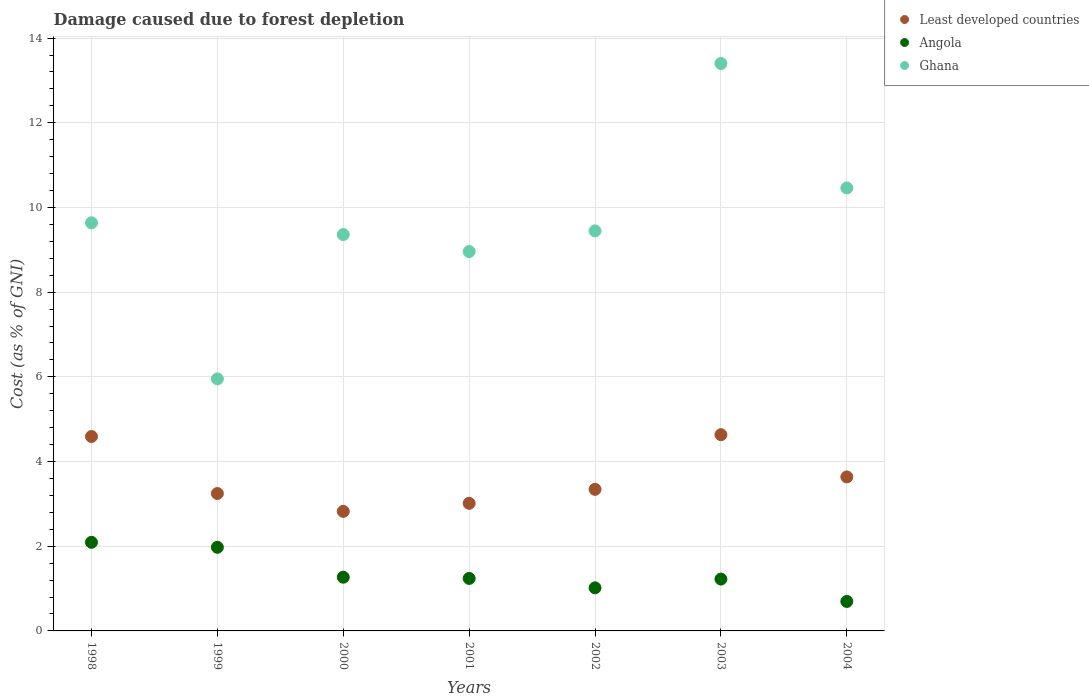Is the number of dotlines equal to the number of legend labels?
Provide a succinct answer. Yes. What is the cost of damage caused due to forest depletion in Least developed countries in 2002?
Make the answer very short. 3.34. Across all years, what is the maximum cost of damage caused due to forest depletion in Ghana?
Offer a very short reply. 13.4. Across all years, what is the minimum cost of damage caused due to forest depletion in Ghana?
Your response must be concise. 5.95. In which year was the cost of damage caused due to forest depletion in Ghana maximum?
Give a very brief answer. 2003. In which year was the cost of damage caused due to forest depletion in Angola minimum?
Your answer should be very brief. 2004. What is the total cost of damage caused due to forest depletion in Angola in the graph?
Your answer should be very brief. 9.51. What is the difference between the cost of damage caused due to forest depletion in Least developed countries in 1998 and that in 2000?
Offer a terse response. 1.77. What is the difference between the cost of damage caused due to forest depletion in Least developed countries in 1999 and the cost of damage caused due to forest depletion in Angola in 2000?
Offer a terse response. 1.98. What is the average cost of damage caused due to forest depletion in Ghana per year?
Make the answer very short. 9.6. In the year 2004, what is the difference between the cost of damage caused due to forest depletion in Angola and cost of damage caused due to forest depletion in Ghana?
Your answer should be very brief. -9.76. In how many years, is the cost of damage caused due to forest depletion in Least developed countries greater than 8 %?
Provide a short and direct response. 0. What is the ratio of the cost of damage caused due to forest depletion in Ghana in 1999 to that in 2001?
Ensure brevity in your answer.  0.66. Is the cost of damage caused due to forest depletion in Angola in 2000 less than that in 2004?
Your response must be concise. No. What is the difference between the highest and the second highest cost of damage caused due to forest depletion in Least developed countries?
Your answer should be very brief. 0.04. What is the difference between the highest and the lowest cost of damage caused due to forest depletion in Ghana?
Your answer should be compact. 7.45. Is the sum of the cost of damage caused due to forest depletion in Angola in 2002 and 2004 greater than the maximum cost of damage caused due to forest depletion in Ghana across all years?
Offer a very short reply. No. Is it the case that in every year, the sum of the cost of damage caused due to forest depletion in Angola and cost of damage caused due to forest depletion in Least developed countries  is greater than the cost of damage caused due to forest depletion in Ghana?
Give a very brief answer. No. Does the cost of damage caused due to forest depletion in Least developed countries monotonically increase over the years?
Ensure brevity in your answer.  No. Is the cost of damage caused due to forest depletion in Least developed countries strictly greater than the cost of damage caused due to forest depletion in Angola over the years?
Offer a very short reply. Yes. How many dotlines are there?
Ensure brevity in your answer.  3. What is the difference between two consecutive major ticks on the Y-axis?
Your answer should be compact. 2. Are the values on the major ticks of Y-axis written in scientific E-notation?
Give a very brief answer. No. Does the graph contain grids?
Provide a succinct answer. Yes. How many legend labels are there?
Your response must be concise. 3. What is the title of the graph?
Make the answer very short. Damage caused due to forest depletion. What is the label or title of the X-axis?
Keep it short and to the point. Years. What is the label or title of the Y-axis?
Provide a succinct answer. Cost (as % of GNI). What is the Cost (as % of GNI) in Least developed countries in 1998?
Give a very brief answer. 4.59. What is the Cost (as % of GNI) in Angola in 1998?
Your response must be concise. 2.09. What is the Cost (as % of GNI) in Ghana in 1998?
Give a very brief answer. 9.64. What is the Cost (as % of GNI) of Least developed countries in 1999?
Provide a succinct answer. 3.25. What is the Cost (as % of GNI) in Angola in 1999?
Offer a very short reply. 1.97. What is the Cost (as % of GNI) of Ghana in 1999?
Your answer should be compact. 5.95. What is the Cost (as % of GNI) of Least developed countries in 2000?
Keep it short and to the point. 2.82. What is the Cost (as % of GNI) in Angola in 2000?
Offer a terse response. 1.27. What is the Cost (as % of GNI) of Ghana in 2000?
Give a very brief answer. 9.36. What is the Cost (as % of GNI) in Least developed countries in 2001?
Provide a succinct answer. 3.01. What is the Cost (as % of GNI) of Angola in 2001?
Ensure brevity in your answer.  1.24. What is the Cost (as % of GNI) in Ghana in 2001?
Provide a succinct answer. 8.96. What is the Cost (as % of GNI) in Least developed countries in 2002?
Provide a short and direct response. 3.34. What is the Cost (as % of GNI) of Angola in 2002?
Make the answer very short. 1.02. What is the Cost (as % of GNI) in Ghana in 2002?
Ensure brevity in your answer.  9.45. What is the Cost (as % of GNI) in Least developed countries in 2003?
Your response must be concise. 4.63. What is the Cost (as % of GNI) of Angola in 2003?
Your answer should be very brief. 1.22. What is the Cost (as % of GNI) of Ghana in 2003?
Keep it short and to the point. 13.4. What is the Cost (as % of GNI) in Least developed countries in 2004?
Your answer should be very brief. 3.64. What is the Cost (as % of GNI) of Angola in 2004?
Make the answer very short. 0.7. What is the Cost (as % of GNI) of Ghana in 2004?
Give a very brief answer. 10.46. Across all years, what is the maximum Cost (as % of GNI) of Least developed countries?
Offer a terse response. 4.63. Across all years, what is the maximum Cost (as % of GNI) in Angola?
Provide a succinct answer. 2.09. Across all years, what is the maximum Cost (as % of GNI) of Ghana?
Make the answer very short. 13.4. Across all years, what is the minimum Cost (as % of GNI) of Least developed countries?
Provide a succinct answer. 2.82. Across all years, what is the minimum Cost (as % of GNI) of Angola?
Keep it short and to the point. 0.7. Across all years, what is the minimum Cost (as % of GNI) in Ghana?
Provide a succinct answer. 5.95. What is the total Cost (as % of GNI) in Least developed countries in the graph?
Make the answer very short. 25.29. What is the total Cost (as % of GNI) of Angola in the graph?
Provide a short and direct response. 9.51. What is the total Cost (as % of GNI) in Ghana in the graph?
Provide a short and direct response. 67.21. What is the difference between the Cost (as % of GNI) in Least developed countries in 1998 and that in 1999?
Offer a terse response. 1.35. What is the difference between the Cost (as % of GNI) of Angola in 1998 and that in 1999?
Make the answer very short. 0.12. What is the difference between the Cost (as % of GNI) in Ghana in 1998 and that in 1999?
Your response must be concise. 3.69. What is the difference between the Cost (as % of GNI) in Least developed countries in 1998 and that in 2000?
Keep it short and to the point. 1.77. What is the difference between the Cost (as % of GNI) of Angola in 1998 and that in 2000?
Make the answer very short. 0.82. What is the difference between the Cost (as % of GNI) of Ghana in 1998 and that in 2000?
Make the answer very short. 0.28. What is the difference between the Cost (as % of GNI) of Least developed countries in 1998 and that in 2001?
Keep it short and to the point. 1.58. What is the difference between the Cost (as % of GNI) in Angola in 1998 and that in 2001?
Your response must be concise. 0.85. What is the difference between the Cost (as % of GNI) of Ghana in 1998 and that in 2001?
Your answer should be compact. 0.68. What is the difference between the Cost (as % of GNI) in Least developed countries in 1998 and that in 2002?
Offer a very short reply. 1.25. What is the difference between the Cost (as % of GNI) in Angola in 1998 and that in 2002?
Your answer should be very brief. 1.07. What is the difference between the Cost (as % of GNI) in Ghana in 1998 and that in 2002?
Make the answer very short. 0.19. What is the difference between the Cost (as % of GNI) of Least developed countries in 1998 and that in 2003?
Your response must be concise. -0.04. What is the difference between the Cost (as % of GNI) in Angola in 1998 and that in 2003?
Your answer should be compact. 0.87. What is the difference between the Cost (as % of GNI) in Ghana in 1998 and that in 2003?
Provide a succinct answer. -3.76. What is the difference between the Cost (as % of GNI) in Least developed countries in 1998 and that in 2004?
Your answer should be very brief. 0.95. What is the difference between the Cost (as % of GNI) in Angola in 1998 and that in 2004?
Provide a succinct answer. 1.4. What is the difference between the Cost (as % of GNI) of Ghana in 1998 and that in 2004?
Keep it short and to the point. -0.82. What is the difference between the Cost (as % of GNI) of Least developed countries in 1999 and that in 2000?
Your response must be concise. 0.42. What is the difference between the Cost (as % of GNI) of Angola in 1999 and that in 2000?
Provide a short and direct response. 0.71. What is the difference between the Cost (as % of GNI) of Ghana in 1999 and that in 2000?
Ensure brevity in your answer.  -3.41. What is the difference between the Cost (as % of GNI) in Least developed countries in 1999 and that in 2001?
Provide a succinct answer. 0.23. What is the difference between the Cost (as % of GNI) in Angola in 1999 and that in 2001?
Your answer should be very brief. 0.74. What is the difference between the Cost (as % of GNI) of Ghana in 1999 and that in 2001?
Offer a terse response. -3.01. What is the difference between the Cost (as % of GNI) in Least developed countries in 1999 and that in 2002?
Keep it short and to the point. -0.1. What is the difference between the Cost (as % of GNI) of Angola in 1999 and that in 2002?
Give a very brief answer. 0.96. What is the difference between the Cost (as % of GNI) in Ghana in 1999 and that in 2002?
Offer a very short reply. -3.49. What is the difference between the Cost (as % of GNI) in Least developed countries in 1999 and that in 2003?
Your response must be concise. -1.39. What is the difference between the Cost (as % of GNI) in Angola in 1999 and that in 2003?
Your response must be concise. 0.75. What is the difference between the Cost (as % of GNI) in Ghana in 1999 and that in 2003?
Provide a succinct answer. -7.45. What is the difference between the Cost (as % of GNI) of Least developed countries in 1999 and that in 2004?
Give a very brief answer. -0.39. What is the difference between the Cost (as % of GNI) of Angola in 1999 and that in 2004?
Your answer should be compact. 1.28. What is the difference between the Cost (as % of GNI) in Ghana in 1999 and that in 2004?
Provide a short and direct response. -4.51. What is the difference between the Cost (as % of GNI) in Least developed countries in 2000 and that in 2001?
Make the answer very short. -0.19. What is the difference between the Cost (as % of GNI) of Angola in 2000 and that in 2001?
Give a very brief answer. 0.03. What is the difference between the Cost (as % of GNI) in Ghana in 2000 and that in 2001?
Your response must be concise. 0.4. What is the difference between the Cost (as % of GNI) in Least developed countries in 2000 and that in 2002?
Offer a very short reply. -0.52. What is the difference between the Cost (as % of GNI) in Angola in 2000 and that in 2002?
Give a very brief answer. 0.25. What is the difference between the Cost (as % of GNI) of Ghana in 2000 and that in 2002?
Ensure brevity in your answer.  -0.09. What is the difference between the Cost (as % of GNI) in Least developed countries in 2000 and that in 2003?
Give a very brief answer. -1.81. What is the difference between the Cost (as % of GNI) in Angola in 2000 and that in 2003?
Provide a short and direct response. 0.04. What is the difference between the Cost (as % of GNI) of Ghana in 2000 and that in 2003?
Provide a succinct answer. -4.04. What is the difference between the Cost (as % of GNI) in Least developed countries in 2000 and that in 2004?
Offer a terse response. -0.81. What is the difference between the Cost (as % of GNI) in Angola in 2000 and that in 2004?
Give a very brief answer. 0.57. What is the difference between the Cost (as % of GNI) in Ghana in 2000 and that in 2004?
Your response must be concise. -1.1. What is the difference between the Cost (as % of GNI) of Least developed countries in 2001 and that in 2002?
Ensure brevity in your answer.  -0.33. What is the difference between the Cost (as % of GNI) in Angola in 2001 and that in 2002?
Provide a succinct answer. 0.22. What is the difference between the Cost (as % of GNI) of Ghana in 2001 and that in 2002?
Offer a terse response. -0.49. What is the difference between the Cost (as % of GNI) in Least developed countries in 2001 and that in 2003?
Ensure brevity in your answer.  -1.62. What is the difference between the Cost (as % of GNI) in Angola in 2001 and that in 2003?
Keep it short and to the point. 0.01. What is the difference between the Cost (as % of GNI) in Ghana in 2001 and that in 2003?
Give a very brief answer. -4.44. What is the difference between the Cost (as % of GNI) in Least developed countries in 2001 and that in 2004?
Provide a succinct answer. -0.62. What is the difference between the Cost (as % of GNI) of Angola in 2001 and that in 2004?
Provide a succinct answer. 0.54. What is the difference between the Cost (as % of GNI) in Ghana in 2001 and that in 2004?
Your answer should be very brief. -1.5. What is the difference between the Cost (as % of GNI) of Least developed countries in 2002 and that in 2003?
Your answer should be very brief. -1.29. What is the difference between the Cost (as % of GNI) in Angola in 2002 and that in 2003?
Offer a terse response. -0.21. What is the difference between the Cost (as % of GNI) in Ghana in 2002 and that in 2003?
Your answer should be very brief. -3.95. What is the difference between the Cost (as % of GNI) of Least developed countries in 2002 and that in 2004?
Make the answer very short. -0.29. What is the difference between the Cost (as % of GNI) in Angola in 2002 and that in 2004?
Provide a succinct answer. 0.32. What is the difference between the Cost (as % of GNI) in Ghana in 2002 and that in 2004?
Keep it short and to the point. -1.01. What is the difference between the Cost (as % of GNI) of Least developed countries in 2003 and that in 2004?
Give a very brief answer. 1. What is the difference between the Cost (as % of GNI) of Angola in 2003 and that in 2004?
Offer a terse response. 0.53. What is the difference between the Cost (as % of GNI) of Ghana in 2003 and that in 2004?
Provide a succinct answer. 2.94. What is the difference between the Cost (as % of GNI) of Least developed countries in 1998 and the Cost (as % of GNI) of Angola in 1999?
Make the answer very short. 2.62. What is the difference between the Cost (as % of GNI) of Least developed countries in 1998 and the Cost (as % of GNI) of Ghana in 1999?
Your answer should be very brief. -1.36. What is the difference between the Cost (as % of GNI) of Angola in 1998 and the Cost (as % of GNI) of Ghana in 1999?
Offer a terse response. -3.86. What is the difference between the Cost (as % of GNI) in Least developed countries in 1998 and the Cost (as % of GNI) in Angola in 2000?
Offer a very short reply. 3.32. What is the difference between the Cost (as % of GNI) in Least developed countries in 1998 and the Cost (as % of GNI) in Ghana in 2000?
Your answer should be compact. -4.77. What is the difference between the Cost (as % of GNI) of Angola in 1998 and the Cost (as % of GNI) of Ghana in 2000?
Offer a terse response. -7.27. What is the difference between the Cost (as % of GNI) of Least developed countries in 1998 and the Cost (as % of GNI) of Angola in 2001?
Your response must be concise. 3.35. What is the difference between the Cost (as % of GNI) of Least developed countries in 1998 and the Cost (as % of GNI) of Ghana in 2001?
Make the answer very short. -4.37. What is the difference between the Cost (as % of GNI) in Angola in 1998 and the Cost (as % of GNI) in Ghana in 2001?
Keep it short and to the point. -6.87. What is the difference between the Cost (as % of GNI) of Least developed countries in 1998 and the Cost (as % of GNI) of Angola in 2002?
Provide a short and direct response. 3.57. What is the difference between the Cost (as % of GNI) in Least developed countries in 1998 and the Cost (as % of GNI) in Ghana in 2002?
Ensure brevity in your answer.  -4.86. What is the difference between the Cost (as % of GNI) in Angola in 1998 and the Cost (as % of GNI) in Ghana in 2002?
Offer a very short reply. -7.35. What is the difference between the Cost (as % of GNI) of Least developed countries in 1998 and the Cost (as % of GNI) of Angola in 2003?
Ensure brevity in your answer.  3.37. What is the difference between the Cost (as % of GNI) of Least developed countries in 1998 and the Cost (as % of GNI) of Ghana in 2003?
Provide a short and direct response. -8.81. What is the difference between the Cost (as % of GNI) in Angola in 1998 and the Cost (as % of GNI) in Ghana in 2003?
Provide a succinct answer. -11.31. What is the difference between the Cost (as % of GNI) in Least developed countries in 1998 and the Cost (as % of GNI) in Angola in 2004?
Give a very brief answer. 3.9. What is the difference between the Cost (as % of GNI) in Least developed countries in 1998 and the Cost (as % of GNI) in Ghana in 2004?
Keep it short and to the point. -5.87. What is the difference between the Cost (as % of GNI) in Angola in 1998 and the Cost (as % of GNI) in Ghana in 2004?
Provide a succinct answer. -8.37. What is the difference between the Cost (as % of GNI) of Least developed countries in 1999 and the Cost (as % of GNI) of Angola in 2000?
Offer a terse response. 1.98. What is the difference between the Cost (as % of GNI) of Least developed countries in 1999 and the Cost (as % of GNI) of Ghana in 2000?
Your answer should be very brief. -6.11. What is the difference between the Cost (as % of GNI) of Angola in 1999 and the Cost (as % of GNI) of Ghana in 2000?
Provide a short and direct response. -7.38. What is the difference between the Cost (as % of GNI) in Least developed countries in 1999 and the Cost (as % of GNI) in Angola in 2001?
Ensure brevity in your answer.  2.01. What is the difference between the Cost (as % of GNI) in Least developed countries in 1999 and the Cost (as % of GNI) in Ghana in 2001?
Your answer should be compact. -5.71. What is the difference between the Cost (as % of GNI) of Angola in 1999 and the Cost (as % of GNI) of Ghana in 2001?
Give a very brief answer. -6.98. What is the difference between the Cost (as % of GNI) in Least developed countries in 1999 and the Cost (as % of GNI) in Angola in 2002?
Your answer should be compact. 2.23. What is the difference between the Cost (as % of GNI) in Least developed countries in 1999 and the Cost (as % of GNI) in Ghana in 2002?
Provide a short and direct response. -6.2. What is the difference between the Cost (as % of GNI) in Angola in 1999 and the Cost (as % of GNI) in Ghana in 2002?
Give a very brief answer. -7.47. What is the difference between the Cost (as % of GNI) in Least developed countries in 1999 and the Cost (as % of GNI) in Angola in 2003?
Make the answer very short. 2.02. What is the difference between the Cost (as % of GNI) of Least developed countries in 1999 and the Cost (as % of GNI) of Ghana in 2003?
Your response must be concise. -10.16. What is the difference between the Cost (as % of GNI) in Angola in 1999 and the Cost (as % of GNI) in Ghana in 2003?
Provide a succinct answer. -11.43. What is the difference between the Cost (as % of GNI) of Least developed countries in 1999 and the Cost (as % of GNI) of Angola in 2004?
Offer a terse response. 2.55. What is the difference between the Cost (as % of GNI) in Least developed countries in 1999 and the Cost (as % of GNI) in Ghana in 2004?
Your answer should be very brief. -7.22. What is the difference between the Cost (as % of GNI) of Angola in 1999 and the Cost (as % of GNI) of Ghana in 2004?
Your answer should be compact. -8.49. What is the difference between the Cost (as % of GNI) in Least developed countries in 2000 and the Cost (as % of GNI) in Angola in 2001?
Give a very brief answer. 1.58. What is the difference between the Cost (as % of GNI) in Least developed countries in 2000 and the Cost (as % of GNI) in Ghana in 2001?
Make the answer very short. -6.14. What is the difference between the Cost (as % of GNI) in Angola in 2000 and the Cost (as % of GNI) in Ghana in 2001?
Provide a succinct answer. -7.69. What is the difference between the Cost (as % of GNI) in Least developed countries in 2000 and the Cost (as % of GNI) in Angola in 2002?
Keep it short and to the point. 1.81. What is the difference between the Cost (as % of GNI) in Least developed countries in 2000 and the Cost (as % of GNI) in Ghana in 2002?
Your response must be concise. -6.62. What is the difference between the Cost (as % of GNI) in Angola in 2000 and the Cost (as % of GNI) in Ghana in 2002?
Provide a succinct answer. -8.18. What is the difference between the Cost (as % of GNI) of Least developed countries in 2000 and the Cost (as % of GNI) of Angola in 2003?
Your response must be concise. 1.6. What is the difference between the Cost (as % of GNI) of Least developed countries in 2000 and the Cost (as % of GNI) of Ghana in 2003?
Provide a succinct answer. -10.58. What is the difference between the Cost (as % of GNI) in Angola in 2000 and the Cost (as % of GNI) in Ghana in 2003?
Give a very brief answer. -12.13. What is the difference between the Cost (as % of GNI) in Least developed countries in 2000 and the Cost (as % of GNI) in Angola in 2004?
Provide a short and direct response. 2.13. What is the difference between the Cost (as % of GNI) in Least developed countries in 2000 and the Cost (as % of GNI) in Ghana in 2004?
Your response must be concise. -7.64. What is the difference between the Cost (as % of GNI) in Angola in 2000 and the Cost (as % of GNI) in Ghana in 2004?
Give a very brief answer. -9.19. What is the difference between the Cost (as % of GNI) in Least developed countries in 2001 and the Cost (as % of GNI) in Angola in 2002?
Offer a terse response. 2. What is the difference between the Cost (as % of GNI) in Least developed countries in 2001 and the Cost (as % of GNI) in Ghana in 2002?
Your answer should be very brief. -6.43. What is the difference between the Cost (as % of GNI) in Angola in 2001 and the Cost (as % of GNI) in Ghana in 2002?
Keep it short and to the point. -8.21. What is the difference between the Cost (as % of GNI) in Least developed countries in 2001 and the Cost (as % of GNI) in Angola in 2003?
Offer a very short reply. 1.79. What is the difference between the Cost (as % of GNI) in Least developed countries in 2001 and the Cost (as % of GNI) in Ghana in 2003?
Offer a terse response. -10.39. What is the difference between the Cost (as % of GNI) of Angola in 2001 and the Cost (as % of GNI) of Ghana in 2003?
Ensure brevity in your answer.  -12.16. What is the difference between the Cost (as % of GNI) in Least developed countries in 2001 and the Cost (as % of GNI) in Angola in 2004?
Offer a terse response. 2.32. What is the difference between the Cost (as % of GNI) of Least developed countries in 2001 and the Cost (as % of GNI) of Ghana in 2004?
Give a very brief answer. -7.45. What is the difference between the Cost (as % of GNI) of Angola in 2001 and the Cost (as % of GNI) of Ghana in 2004?
Provide a succinct answer. -9.22. What is the difference between the Cost (as % of GNI) of Least developed countries in 2002 and the Cost (as % of GNI) of Angola in 2003?
Ensure brevity in your answer.  2.12. What is the difference between the Cost (as % of GNI) of Least developed countries in 2002 and the Cost (as % of GNI) of Ghana in 2003?
Your answer should be very brief. -10.06. What is the difference between the Cost (as % of GNI) of Angola in 2002 and the Cost (as % of GNI) of Ghana in 2003?
Provide a short and direct response. -12.38. What is the difference between the Cost (as % of GNI) in Least developed countries in 2002 and the Cost (as % of GNI) in Angola in 2004?
Your answer should be compact. 2.65. What is the difference between the Cost (as % of GNI) in Least developed countries in 2002 and the Cost (as % of GNI) in Ghana in 2004?
Your response must be concise. -7.12. What is the difference between the Cost (as % of GNI) of Angola in 2002 and the Cost (as % of GNI) of Ghana in 2004?
Your answer should be compact. -9.44. What is the difference between the Cost (as % of GNI) in Least developed countries in 2003 and the Cost (as % of GNI) in Angola in 2004?
Keep it short and to the point. 3.94. What is the difference between the Cost (as % of GNI) of Least developed countries in 2003 and the Cost (as % of GNI) of Ghana in 2004?
Your answer should be compact. -5.83. What is the difference between the Cost (as % of GNI) in Angola in 2003 and the Cost (as % of GNI) in Ghana in 2004?
Your response must be concise. -9.24. What is the average Cost (as % of GNI) in Least developed countries per year?
Provide a short and direct response. 3.61. What is the average Cost (as % of GNI) in Angola per year?
Your response must be concise. 1.36. What is the average Cost (as % of GNI) in Ghana per year?
Offer a terse response. 9.6. In the year 1998, what is the difference between the Cost (as % of GNI) of Least developed countries and Cost (as % of GNI) of Angola?
Ensure brevity in your answer.  2.5. In the year 1998, what is the difference between the Cost (as % of GNI) in Least developed countries and Cost (as % of GNI) in Ghana?
Keep it short and to the point. -5.05. In the year 1998, what is the difference between the Cost (as % of GNI) of Angola and Cost (as % of GNI) of Ghana?
Offer a terse response. -7.54. In the year 1999, what is the difference between the Cost (as % of GNI) in Least developed countries and Cost (as % of GNI) in Angola?
Make the answer very short. 1.27. In the year 1999, what is the difference between the Cost (as % of GNI) of Least developed countries and Cost (as % of GNI) of Ghana?
Keep it short and to the point. -2.71. In the year 1999, what is the difference between the Cost (as % of GNI) of Angola and Cost (as % of GNI) of Ghana?
Your response must be concise. -3.98. In the year 2000, what is the difference between the Cost (as % of GNI) in Least developed countries and Cost (as % of GNI) in Angola?
Provide a succinct answer. 1.55. In the year 2000, what is the difference between the Cost (as % of GNI) of Least developed countries and Cost (as % of GNI) of Ghana?
Your response must be concise. -6.54. In the year 2000, what is the difference between the Cost (as % of GNI) in Angola and Cost (as % of GNI) in Ghana?
Your answer should be very brief. -8.09. In the year 2001, what is the difference between the Cost (as % of GNI) of Least developed countries and Cost (as % of GNI) of Angola?
Your response must be concise. 1.77. In the year 2001, what is the difference between the Cost (as % of GNI) of Least developed countries and Cost (as % of GNI) of Ghana?
Ensure brevity in your answer.  -5.95. In the year 2001, what is the difference between the Cost (as % of GNI) in Angola and Cost (as % of GNI) in Ghana?
Offer a very short reply. -7.72. In the year 2002, what is the difference between the Cost (as % of GNI) of Least developed countries and Cost (as % of GNI) of Angola?
Give a very brief answer. 2.33. In the year 2002, what is the difference between the Cost (as % of GNI) in Least developed countries and Cost (as % of GNI) in Ghana?
Provide a short and direct response. -6.1. In the year 2002, what is the difference between the Cost (as % of GNI) in Angola and Cost (as % of GNI) in Ghana?
Keep it short and to the point. -8.43. In the year 2003, what is the difference between the Cost (as % of GNI) in Least developed countries and Cost (as % of GNI) in Angola?
Provide a short and direct response. 3.41. In the year 2003, what is the difference between the Cost (as % of GNI) in Least developed countries and Cost (as % of GNI) in Ghana?
Offer a very short reply. -8.77. In the year 2003, what is the difference between the Cost (as % of GNI) of Angola and Cost (as % of GNI) of Ghana?
Keep it short and to the point. -12.18. In the year 2004, what is the difference between the Cost (as % of GNI) of Least developed countries and Cost (as % of GNI) of Angola?
Make the answer very short. 2.94. In the year 2004, what is the difference between the Cost (as % of GNI) of Least developed countries and Cost (as % of GNI) of Ghana?
Offer a very short reply. -6.82. In the year 2004, what is the difference between the Cost (as % of GNI) of Angola and Cost (as % of GNI) of Ghana?
Give a very brief answer. -9.76. What is the ratio of the Cost (as % of GNI) of Least developed countries in 1998 to that in 1999?
Keep it short and to the point. 1.41. What is the ratio of the Cost (as % of GNI) of Angola in 1998 to that in 1999?
Provide a short and direct response. 1.06. What is the ratio of the Cost (as % of GNI) of Ghana in 1998 to that in 1999?
Offer a very short reply. 1.62. What is the ratio of the Cost (as % of GNI) in Least developed countries in 1998 to that in 2000?
Provide a succinct answer. 1.63. What is the ratio of the Cost (as % of GNI) of Angola in 1998 to that in 2000?
Your answer should be compact. 1.65. What is the ratio of the Cost (as % of GNI) of Ghana in 1998 to that in 2000?
Offer a very short reply. 1.03. What is the ratio of the Cost (as % of GNI) in Least developed countries in 1998 to that in 2001?
Make the answer very short. 1.52. What is the ratio of the Cost (as % of GNI) in Angola in 1998 to that in 2001?
Provide a succinct answer. 1.69. What is the ratio of the Cost (as % of GNI) in Ghana in 1998 to that in 2001?
Your answer should be compact. 1.08. What is the ratio of the Cost (as % of GNI) in Least developed countries in 1998 to that in 2002?
Your answer should be compact. 1.37. What is the ratio of the Cost (as % of GNI) in Angola in 1998 to that in 2002?
Your answer should be very brief. 2.06. What is the ratio of the Cost (as % of GNI) in Ghana in 1998 to that in 2002?
Provide a succinct answer. 1.02. What is the ratio of the Cost (as % of GNI) of Angola in 1998 to that in 2003?
Your answer should be compact. 1.71. What is the ratio of the Cost (as % of GNI) of Ghana in 1998 to that in 2003?
Keep it short and to the point. 0.72. What is the ratio of the Cost (as % of GNI) in Least developed countries in 1998 to that in 2004?
Offer a terse response. 1.26. What is the ratio of the Cost (as % of GNI) in Angola in 1998 to that in 2004?
Make the answer very short. 3.01. What is the ratio of the Cost (as % of GNI) of Ghana in 1998 to that in 2004?
Offer a very short reply. 0.92. What is the ratio of the Cost (as % of GNI) in Least developed countries in 1999 to that in 2000?
Keep it short and to the point. 1.15. What is the ratio of the Cost (as % of GNI) in Angola in 1999 to that in 2000?
Your answer should be very brief. 1.56. What is the ratio of the Cost (as % of GNI) of Ghana in 1999 to that in 2000?
Keep it short and to the point. 0.64. What is the ratio of the Cost (as % of GNI) of Angola in 1999 to that in 2001?
Your answer should be very brief. 1.59. What is the ratio of the Cost (as % of GNI) in Ghana in 1999 to that in 2001?
Offer a terse response. 0.66. What is the ratio of the Cost (as % of GNI) in Least developed countries in 1999 to that in 2002?
Keep it short and to the point. 0.97. What is the ratio of the Cost (as % of GNI) in Angola in 1999 to that in 2002?
Offer a very short reply. 1.94. What is the ratio of the Cost (as % of GNI) in Ghana in 1999 to that in 2002?
Provide a short and direct response. 0.63. What is the ratio of the Cost (as % of GNI) of Least developed countries in 1999 to that in 2003?
Keep it short and to the point. 0.7. What is the ratio of the Cost (as % of GNI) in Angola in 1999 to that in 2003?
Make the answer very short. 1.61. What is the ratio of the Cost (as % of GNI) of Ghana in 1999 to that in 2003?
Offer a very short reply. 0.44. What is the ratio of the Cost (as % of GNI) in Least developed countries in 1999 to that in 2004?
Provide a short and direct response. 0.89. What is the ratio of the Cost (as % of GNI) of Angola in 1999 to that in 2004?
Make the answer very short. 2.84. What is the ratio of the Cost (as % of GNI) of Ghana in 1999 to that in 2004?
Your answer should be compact. 0.57. What is the ratio of the Cost (as % of GNI) in Least developed countries in 2000 to that in 2001?
Offer a terse response. 0.94. What is the ratio of the Cost (as % of GNI) of Angola in 2000 to that in 2001?
Make the answer very short. 1.02. What is the ratio of the Cost (as % of GNI) of Ghana in 2000 to that in 2001?
Make the answer very short. 1.04. What is the ratio of the Cost (as % of GNI) of Least developed countries in 2000 to that in 2002?
Provide a short and direct response. 0.84. What is the ratio of the Cost (as % of GNI) of Angola in 2000 to that in 2002?
Keep it short and to the point. 1.25. What is the ratio of the Cost (as % of GNI) in Ghana in 2000 to that in 2002?
Provide a short and direct response. 0.99. What is the ratio of the Cost (as % of GNI) of Least developed countries in 2000 to that in 2003?
Your answer should be very brief. 0.61. What is the ratio of the Cost (as % of GNI) of Angola in 2000 to that in 2003?
Provide a short and direct response. 1.04. What is the ratio of the Cost (as % of GNI) in Ghana in 2000 to that in 2003?
Your response must be concise. 0.7. What is the ratio of the Cost (as % of GNI) of Least developed countries in 2000 to that in 2004?
Ensure brevity in your answer.  0.78. What is the ratio of the Cost (as % of GNI) in Angola in 2000 to that in 2004?
Offer a very short reply. 1.82. What is the ratio of the Cost (as % of GNI) in Ghana in 2000 to that in 2004?
Make the answer very short. 0.89. What is the ratio of the Cost (as % of GNI) in Least developed countries in 2001 to that in 2002?
Offer a terse response. 0.9. What is the ratio of the Cost (as % of GNI) in Angola in 2001 to that in 2002?
Offer a very short reply. 1.22. What is the ratio of the Cost (as % of GNI) of Ghana in 2001 to that in 2002?
Offer a very short reply. 0.95. What is the ratio of the Cost (as % of GNI) of Least developed countries in 2001 to that in 2003?
Your response must be concise. 0.65. What is the ratio of the Cost (as % of GNI) in Angola in 2001 to that in 2003?
Offer a very short reply. 1.01. What is the ratio of the Cost (as % of GNI) in Ghana in 2001 to that in 2003?
Provide a succinct answer. 0.67. What is the ratio of the Cost (as % of GNI) of Least developed countries in 2001 to that in 2004?
Your answer should be compact. 0.83. What is the ratio of the Cost (as % of GNI) in Angola in 2001 to that in 2004?
Keep it short and to the point. 1.78. What is the ratio of the Cost (as % of GNI) of Ghana in 2001 to that in 2004?
Offer a terse response. 0.86. What is the ratio of the Cost (as % of GNI) of Least developed countries in 2002 to that in 2003?
Your answer should be compact. 0.72. What is the ratio of the Cost (as % of GNI) in Angola in 2002 to that in 2003?
Make the answer very short. 0.83. What is the ratio of the Cost (as % of GNI) of Ghana in 2002 to that in 2003?
Offer a terse response. 0.7. What is the ratio of the Cost (as % of GNI) in Least developed countries in 2002 to that in 2004?
Ensure brevity in your answer.  0.92. What is the ratio of the Cost (as % of GNI) of Angola in 2002 to that in 2004?
Your answer should be compact. 1.46. What is the ratio of the Cost (as % of GNI) of Ghana in 2002 to that in 2004?
Make the answer very short. 0.9. What is the ratio of the Cost (as % of GNI) of Least developed countries in 2003 to that in 2004?
Keep it short and to the point. 1.27. What is the ratio of the Cost (as % of GNI) in Angola in 2003 to that in 2004?
Give a very brief answer. 1.76. What is the ratio of the Cost (as % of GNI) in Ghana in 2003 to that in 2004?
Provide a short and direct response. 1.28. What is the difference between the highest and the second highest Cost (as % of GNI) in Least developed countries?
Offer a terse response. 0.04. What is the difference between the highest and the second highest Cost (as % of GNI) in Angola?
Offer a very short reply. 0.12. What is the difference between the highest and the second highest Cost (as % of GNI) in Ghana?
Provide a short and direct response. 2.94. What is the difference between the highest and the lowest Cost (as % of GNI) in Least developed countries?
Give a very brief answer. 1.81. What is the difference between the highest and the lowest Cost (as % of GNI) in Angola?
Offer a very short reply. 1.4. What is the difference between the highest and the lowest Cost (as % of GNI) of Ghana?
Your answer should be very brief. 7.45. 